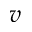Convert formula to latex. <formula><loc_0><loc_0><loc_500><loc_500>v</formula> 